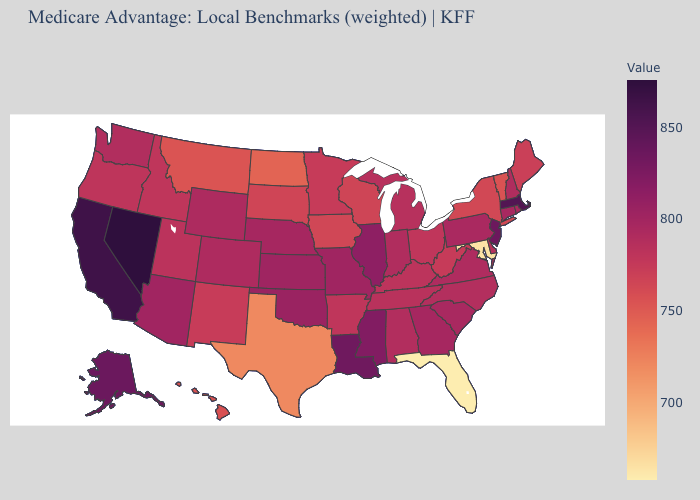Which states have the lowest value in the Northeast?
Keep it brief. Vermont. Which states have the lowest value in the USA?
Give a very brief answer. Florida. Among the states that border Maryland , does Virginia have the highest value?
Write a very short answer. No. Which states have the lowest value in the USA?
Quick response, please. Florida. Does Colorado have a lower value than Massachusetts?
Give a very brief answer. Yes. Does Kansas have a higher value than Louisiana?
Quick response, please. No. Does North Carolina have a higher value than California?
Answer briefly. No. Among the states that border Maryland , does Pennsylvania have the highest value?
Quick response, please. Yes. 